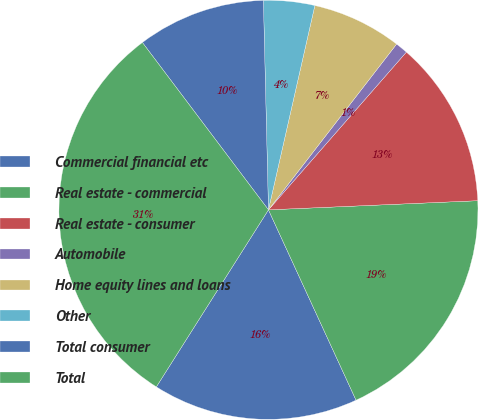Convert chart. <chart><loc_0><loc_0><loc_500><loc_500><pie_chart><fcel>Commercial financial etc<fcel>Real estate - commercial<fcel>Real estate - consumer<fcel>Automobile<fcel>Home equity lines and loans<fcel>Other<fcel>Total consumer<fcel>Total<nl><fcel>15.85%<fcel>18.83%<fcel>12.87%<fcel>0.96%<fcel>6.92%<fcel>3.94%<fcel>9.89%<fcel>30.74%<nl></chart> 